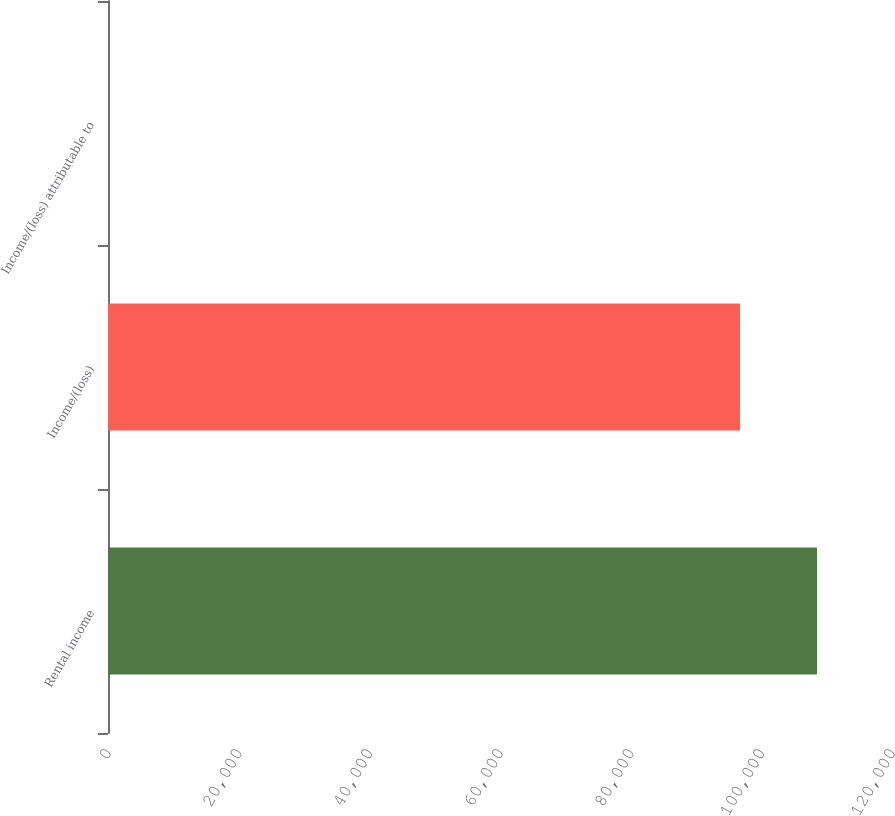Convert chart. <chart><loc_0><loc_0><loc_500><loc_500><bar_chart><fcel>Rental income<fcel>Income/(loss)<fcel>Income/(loss) attributable to<nl><fcel>108523<fcel>96732.2<fcel>0.47<nl></chart> 